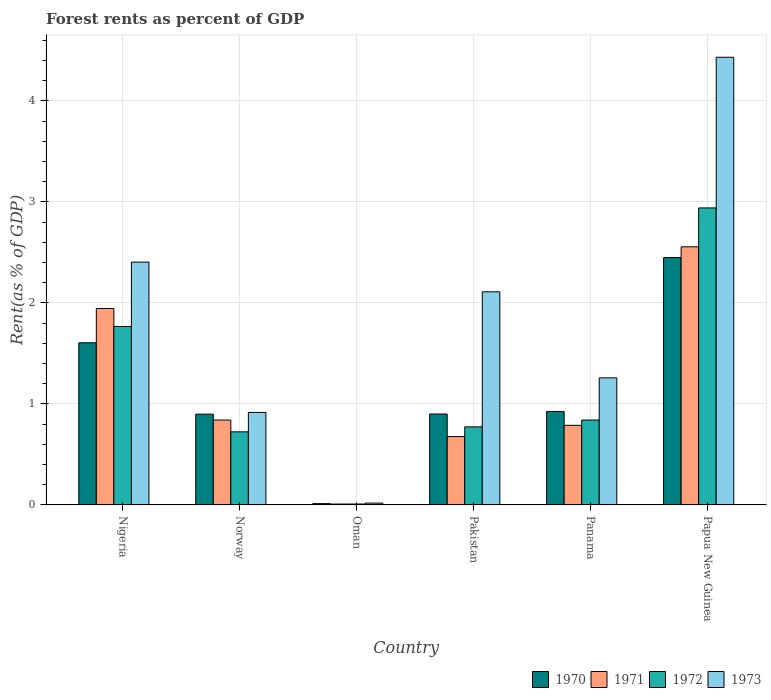How many different coloured bars are there?
Offer a very short reply. 4. How many groups of bars are there?
Your answer should be very brief. 6. How many bars are there on the 1st tick from the right?
Offer a very short reply. 4. What is the label of the 5th group of bars from the left?
Offer a terse response. Panama. In how many cases, is the number of bars for a given country not equal to the number of legend labels?
Offer a very short reply. 0. What is the forest rent in 1972 in Papua New Guinea?
Keep it short and to the point. 2.94. Across all countries, what is the maximum forest rent in 1973?
Provide a short and direct response. 4.43. Across all countries, what is the minimum forest rent in 1972?
Ensure brevity in your answer.  0.01. In which country was the forest rent in 1973 maximum?
Your answer should be very brief. Papua New Guinea. In which country was the forest rent in 1970 minimum?
Offer a very short reply. Oman. What is the total forest rent in 1970 in the graph?
Make the answer very short. 6.79. What is the difference between the forest rent in 1973 in Norway and that in Panama?
Keep it short and to the point. -0.34. What is the difference between the forest rent in 1973 in Pakistan and the forest rent in 1971 in Papua New Guinea?
Your answer should be very brief. -0.45. What is the average forest rent in 1973 per country?
Your answer should be very brief. 1.86. What is the difference between the forest rent of/in 1972 and forest rent of/in 1973 in Pakistan?
Ensure brevity in your answer.  -1.34. In how many countries, is the forest rent in 1972 greater than 4.2 %?
Keep it short and to the point. 0. What is the ratio of the forest rent in 1973 in Oman to that in Pakistan?
Your answer should be compact. 0.01. Is the difference between the forest rent in 1972 in Panama and Papua New Guinea greater than the difference between the forest rent in 1973 in Panama and Papua New Guinea?
Ensure brevity in your answer.  Yes. What is the difference between the highest and the second highest forest rent in 1970?
Give a very brief answer. -0.68. What is the difference between the highest and the lowest forest rent in 1970?
Give a very brief answer. 2.44. In how many countries, is the forest rent in 1973 greater than the average forest rent in 1973 taken over all countries?
Offer a very short reply. 3. Is the sum of the forest rent in 1973 in Oman and Papua New Guinea greater than the maximum forest rent in 1972 across all countries?
Provide a succinct answer. Yes. Is it the case that in every country, the sum of the forest rent in 1972 and forest rent in 1971 is greater than the sum of forest rent in 1970 and forest rent in 1973?
Your answer should be compact. No. What does the 3rd bar from the right in Oman represents?
Offer a very short reply. 1971. Is it the case that in every country, the sum of the forest rent in 1972 and forest rent in 1970 is greater than the forest rent in 1973?
Give a very brief answer. No. Are all the bars in the graph horizontal?
Make the answer very short. No. What is the difference between two consecutive major ticks on the Y-axis?
Your answer should be very brief. 1. Are the values on the major ticks of Y-axis written in scientific E-notation?
Your answer should be very brief. No. Where does the legend appear in the graph?
Your response must be concise. Bottom right. What is the title of the graph?
Your answer should be very brief. Forest rents as percent of GDP. What is the label or title of the Y-axis?
Give a very brief answer. Rent(as % of GDP). What is the Rent(as % of GDP) of 1970 in Nigeria?
Offer a terse response. 1.61. What is the Rent(as % of GDP) of 1971 in Nigeria?
Make the answer very short. 1.94. What is the Rent(as % of GDP) of 1972 in Nigeria?
Provide a succinct answer. 1.77. What is the Rent(as % of GDP) in 1973 in Nigeria?
Offer a very short reply. 2.4. What is the Rent(as % of GDP) in 1970 in Norway?
Your answer should be compact. 0.9. What is the Rent(as % of GDP) of 1971 in Norway?
Your answer should be compact. 0.84. What is the Rent(as % of GDP) of 1972 in Norway?
Ensure brevity in your answer.  0.72. What is the Rent(as % of GDP) of 1973 in Norway?
Give a very brief answer. 0.92. What is the Rent(as % of GDP) in 1970 in Oman?
Offer a terse response. 0.01. What is the Rent(as % of GDP) in 1971 in Oman?
Provide a short and direct response. 0.01. What is the Rent(as % of GDP) of 1972 in Oman?
Keep it short and to the point. 0.01. What is the Rent(as % of GDP) in 1973 in Oman?
Your response must be concise. 0.02. What is the Rent(as % of GDP) in 1970 in Pakistan?
Offer a terse response. 0.9. What is the Rent(as % of GDP) of 1971 in Pakistan?
Provide a succinct answer. 0.68. What is the Rent(as % of GDP) in 1972 in Pakistan?
Make the answer very short. 0.77. What is the Rent(as % of GDP) of 1973 in Pakistan?
Offer a terse response. 2.11. What is the Rent(as % of GDP) of 1970 in Panama?
Offer a very short reply. 0.93. What is the Rent(as % of GDP) in 1971 in Panama?
Provide a succinct answer. 0.79. What is the Rent(as % of GDP) in 1972 in Panama?
Offer a terse response. 0.84. What is the Rent(as % of GDP) of 1973 in Panama?
Provide a succinct answer. 1.26. What is the Rent(as % of GDP) of 1970 in Papua New Guinea?
Provide a succinct answer. 2.45. What is the Rent(as % of GDP) of 1971 in Papua New Guinea?
Your response must be concise. 2.56. What is the Rent(as % of GDP) in 1972 in Papua New Guinea?
Your answer should be compact. 2.94. What is the Rent(as % of GDP) of 1973 in Papua New Guinea?
Provide a short and direct response. 4.43. Across all countries, what is the maximum Rent(as % of GDP) in 1970?
Your answer should be compact. 2.45. Across all countries, what is the maximum Rent(as % of GDP) of 1971?
Offer a terse response. 2.56. Across all countries, what is the maximum Rent(as % of GDP) of 1972?
Give a very brief answer. 2.94. Across all countries, what is the maximum Rent(as % of GDP) of 1973?
Make the answer very short. 4.43. Across all countries, what is the minimum Rent(as % of GDP) of 1970?
Make the answer very short. 0.01. Across all countries, what is the minimum Rent(as % of GDP) of 1971?
Your answer should be compact. 0.01. Across all countries, what is the minimum Rent(as % of GDP) of 1972?
Your response must be concise. 0.01. Across all countries, what is the minimum Rent(as % of GDP) of 1973?
Your response must be concise. 0.02. What is the total Rent(as % of GDP) of 1970 in the graph?
Offer a very short reply. 6.79. What is the total Rent(as % of GDP) in 1971 in the graph?
Provide a succinct answer. 6.81. What is the total Rent(as % of GDP) in 1972 in the graph?
Your response must be concise. 7.05. What is the total Rent(as % of GDP) in 1973 in the graph?
Your answer should be compact. 11.14. What is the difference between the Rent(as % of GDP) of 1970 in Nigeria and that in Norway?
Ensure brevity in your answer.  0.71. What is the difference between the Rent(as % of GDP) in 1971 in Nigeria and that in Norway?
Make the answer very short. 1.1. What is the difference between the Rent(as % of GDP) of 1972 in Nigeria and that in Norway?
Ensure brevity in your answer.  1.04. What is the difference between the Rent(as % of GDP) in 1973 in Nigeria and that in Norway?
Your answer should be compact. 1.49. What is the difference between the Rent(as % of GDP) of 1970 in Nigeria and that in Oman?
Give a very brief answer. 1.59. What is the difference between the Rent(as % of GDP) of 1971 in Nigeria and that in Oman?
Provide a short and direct response. 1.94. What is the difference between the Rent(as % of GDP) in 1972 in Nigeria and that in Oman?
Offer a very short reply. 1.76. What is the difference between the Rent(as % of GDP) in 1973 in Nigeria and that in Oman?
Keep it short and to the point. 2.39. What is the difference between the Rent(as % of GDP) in 1970 in Nigeria and that in Pakistan?
Offer a terse response. 0.7. What is the difference between the Rent(as % of GDP) of 1971 in Nigeria and that in Pakistan?
Provide a short and direct response. 1.27. What is the difference between the Rent(as % of GDP) in 1973 in Nigeria and that in Pakistan?
Provide a short and direct response. 0.29. What is the difference between the Rent(as % of GDP) in 1970 in Nigeria and that in Panama?
Your answer should be very brief. 0.68. What is the difference between the Rent(as % of GDP) of 1971 in Nigeria and that in Panama?
Keep it short and to the point. 1.16. What is the difference between the Rent(as % of GDP) of 1972 in Nigeria and that in Panama?
Your response must be concise. 0.93. What is the difference between the Rent(as % of GDP) of 1973 in Nigeria and that in Panama?
Your answer should be very brief. 1.15. What is the difference between the Rent(as % of GDP) in 1970 in Nigeria and that in Papua New Guinea?
Offer a terse response. -0.84. What is the difference between the Rent(as % of GDP) of 1971 in Nigeria and that in Papua New Guinea?
Offer a terse response. -0.61. What is the difference between the Rent(as % of GDP) of 1972 in Nigeria and that in Papua New Guinea?
Offer a very short reply. -1.17. What is the difference between the Rent(as % of GDP) in 1973 in Nigeria and that in Papua New Guinea?
Ensure brevity in your answer.  -2.03. What is the difference between the Rent(as % of GDP) of 1970 in Norway and that in Oman?
Your answer should be compact. 0.89. What is the difference between the Rent(as % of GDP) in 1971 in Norway and that in Oman?
Your answer should be compact. 0.83. What is the difference between the Rent(as % of GDP) in 1972 in Norway and that in Oman?
Your answer should be compact. 0.71. What is the difference between the Rent(as % of GDP) of 1973 in Norway and that in Oman?
Make the answer very short. 0.9. What is the difference between the Rent(as % of GDP) in 1970 in Norway and that in Pakistan?
Provide a short and direct response. -0. What is the difference between the Rent(as % of GDP) in 1971 in Norway and that in Pakistan?
Your response must be concise. 0.16. What is the difference between the Rent(as % of GDP) of 1972 in Norway and that in Pakistan?
Provide a succinct answer. -0.05. What is the difference between the Rent(as % of GDP) of 1973 in Norway and that in Pakistan?
Give a very brief answer. -1.19. What is the difference between the Rent(as % of GDP) of 1970 in Norway and that in Panama?
Provide a succinct answer. -0.03. What is the difference between the Rent(as % of GDP) in 1971 in Norway and that in Panama?
Your answer should be compact. 0.05. What is the difference between the Rent(as % of GDP) of 1972 in Norway and that in Panama?
Offer a terse response. -0.12. What is the difference between the Rent(as % of GDP) of 1973 in Norway and that in Panama?
Give a very brief answer. -0.34. What is the difference between the Rent(as % of GDP) of 1970 in Norway and that in Papua New Guinea?
Your answer should be very brief. -1.55. What is the difference between the Rent(as % of GDP) of 1971 in Norway and that in Papua New Guinea?
Your answer should be compact. -1.72. What is the difference between the Rent(as % of GDP) in 1972 in Norway and that in Papua New Guinea?
Offer a terse response. -2.22. What is the difference between the Rent(as % of GDP) in 1973 in Norway and that in Papua New Guinea?
Your answer should be compact. -3.52. What is the difference between the Rent(as % of GDP) of 1970 in Oman and that in Pakistan?
Your answer should be compact. -0.89. What is the difference between the Rent(as % of GDP) of 1971 in Oman and that in Pakistan?
Keep it short and to the point. -0.67. What is the difference between the Rent(as % of GDP) of 1972 in Oman and that in Pakistan?
Offer a very short reply. -0.76. What is the difference between the Rent(as % of GDP) of 1973 in Oman and that in Pakistan?
Your response must be concise. -2.09. What is the difference between the Rent(as % of GDP) of 1970 in Oman and that in Panama?
Provide a succinct answer. -0.91. What is the difference between the Rent(as % of GDP) in 1971 in Oman and that in Panama?
Provide a succinct answer. -0.78. What is the difference between the Rent(as % of GDP) of 1972 in Oman and that in Panama?
Your response must be concise. -0.83. What is the difference between the Rent(as % of GDP) of 1973 in Oman and that in Panama?
Keep it short and to the point. -1.24. What is the difference between the Rent(as % of GDP) in 1970 in Oman and that in Papua New Guinea?
Ensure brevity in your answer.  -2.44. What is the difference between the Rent(as % of GDP) in 1971 in Oman and that in Papua New Guinea?
Provide a short and direct response. -2.55. What is the difference between the Rent(as % of GDP) of 1972 in Oman and that in Papua New Guinea?
Offer a terse response. -2.93. What is the difference between the Rent(as % of GDP) of 1973 in Oman and that in Papua New Guinea?
Give a very brief answer. -4.41. What is the difference between the Rent(as % of GDP) of 1970 in Pakistan and that in Panama?
Your response must be concise. -0.03. What is the difference between the Rent(as % of GDP) of 1971 in Pakistan and that in Panama?
Offer a terse response. -0.11. What is the difference between the Rent(as % of GDP) of 1972 in Pakistan and that in Panama?
Keep it short and to the point. -0.07. What is the difference between the Rent(as % of GDP) of 1973 in Pakistan and that in Panama?
Give a very brief answer. 0.85. What is the difference between the Rent(as % of GDP) of 1970 in Pakistan and that in Papua New Guinea?
Your response must be concise. -1.55. What is the difference between the Rent(as % of GDP) in 1971 in Pakistan and that in Papua New Guinea?
Offer a terse response. -1.88. What is the difference between the Rent(as % of GDP) in 1972 in Pakistan and that in Papua New Guinea?
Give a very brief answer. -2.17. What is the difference between the Rent(as % of GDP) in 1973 in Pakistan and that in Papua New Guinea?
Give a very brief answer. -2.32. What is the difference between the Rent(as % of GDP) of 1970 in Panama and that in Papua New Guinea?
Provide a succinct answer. -1.52. What is the difference between the Rent(as % of GDP) in 1971 in Panama and that in Papua New Guinea?
Your answer should be very brief. -1.77. What is the difference between the Rent(as % of GDP) of 1973 in Panama and that in Papua New Guinea?
Offer a terse response. -3.17. What is the difference between the Rent(as % of GDP) of 1970 in Nigeria and the Rent(as % of GDP) of 1971 in Norway?
Provide a succinct answer. 0.76. What is the difference between the Rent(as % of GDP) in 1970 in Nigeria and the Rent(as % of GDP) in 1972 in Norway?
Offer a terse response. 0.88. What is the difference between the Rent(as % of GDP) in 1970 in Nigeria and the Rent(as % of GDP) in 1973 in Norway?
Your answer should be very brief. 0.69. What is the difference between the Rent(as % of GDP) of 1971 in Nigeria and the Rent(as % of GDP) of 1972 in Norway?
Provide a succinct answer. 1.22. What is the difference between the Rent(as % of GDP) of 1972 in Nigeria and the Rent(as % of GDP) of 1973 in Norway?
Your answer should be compact. 0.85. What is the difference between the Rent(as % of GDP) of 1970 in Nigeria and the Rent(as % of GDP) of 1971 in Oman?
Ensure brevity in your answer.  1.6. What is the difference between the Rent(as % of GDP) of 1970 in Nigeria and the Rent(as % of GDP) of 1972 in Oman?
Your response must be concise. 1.6. What is the difference between the Rent(as % of GDP) of 1970 in Nigeria and the Rent(as % of GDP) of 1973 in Oman?
Offer a terse response. 1.59. What is the difference between the Rent(as % of GDP) in 1971 in Nigeria and the Rent(as % of GDP) in 1972 in Oman?
Offer a very short reply. 1.94. What is the difference between the Rent(as % of GDP) of 1971 in Nigeria and the Rent(as % of GDP) of 1973 in Oman?
Your answer should be compact. 1.93. What is the difference between the Rent(as % of GDP) in 1972 in Nigeria and the Rent(as % of GDP) in 1973 in Oman?
Provide a succinct answer. 1.75. What is the difference between the Rent(as % of GDP) of 1970 in Nigeria and the Rent(as % of GDP) of 1971 in Pakistan?
Provide a short and direct response. 0.93. What is the difference between the Rent(as % of GDP) of 1970 in Nigeria and the Rent(as % of GDP) of 1972 in Pakistan?
Offer a terse response. 0.83. What is the difference between the Rent(as % of GDP) of 1970 in Nigeria and the Rent(as % of GDP) of 1973 in Pakistan?
Provide a succinct answer. -0.5. What is the difference between the Rent(as % of GDP) in 1971 in Nigeria and the Rent(as % of GDP) in 1972 in Pakistan?
Provide a succinct answer. 1.17. What is the difference between the Rent(as % of GDP) of 1971 in Nigeria and the Rent(as % of GDP) of 1973 in Pakistan?
Provide a succinct answer. -0.17. What is the difference between the Rent(as % of GDP) of 1972 in Nigeria and the Rent(as % of GDP) of 1973 in Pakistan?
Provide a short and direct response. -0.34. What is the difference between the Rent(as % of GDP) of 1970 in Nigeria and the Rent(as % of GDP) of 1971 in Panama?
Offer a very short reply. 0.82. What is the difference between the Rent(as % of GDP) in 1970 in Nigeria and the Rent(as % of GDP) in 1972 in Panama?
Provide a succinct answer. 0.76. What is the difference between the Rent(as % of GDP) in 1970 in Nigeria and the Rent(as % of GDP) in 1973 in Panama?
Offer a very short reply. 0.35. What is the difference between the Rent(as % of GDP) of 1971 in Nigeria and the Rent(as % of GDP) of 1972 in Panama?
Your answer should be compact. 1.1. What is the difference between the Rent(as % of GDP) in 1971 in Nigeria and the Rent(as % of GDP) in 1973 in Panama?
Give a very brief answer. 0.69. What is the difference between the Rent(as % of GDP) of 1972 in Nigeria and the Rent(as % of GDP) of 1973 in Panama?
Your answer should be compact. 0.51. What is the difference between the Rent(as % of GDP) in 1970 in Nigeria and the Rent(as % of GDP) in 1971 in Papua New Guinea?
Keep it short and to the point. -0.95. What is the difference between the Rent(as % of GDP) of 1970 in Nigeria and the Rent(as % of GDP) of 1972 in Papua New Guinea?
Your response must be concise. -1.34. What is the difference between the Rent(as % of GDP) of 1970 in Nigeria and the Rent(as % of GDP) of 1973 in Papua New Guinea?
Keep it short and to the point. -2.83. What is the difference between the Rent(as % of GDP) in 1971 in Nigeria and the Rent(as % of GDP) in 1972 in Papua New Guinea?
Your response must be concise. -1. What is the difference between the Rent(as % of GDP) in 1971 in Nigeria and the Rent(as % of GDP) in 1973 in Papua New Guinea?
Your answer should be compact. -2.49. What is the difference between the Rent(as % of GDP) of 1972 in Nigeria and the Rent(as % of GDP) of 1973 in Papua New Guinea?
Make the answer very short. -2.66. What is the difference between the Rent(as % of GDP) of 1970 in Norway and the Rent(as % of GDP) of 1971 in Oman?
Your answer should be very brief. 0.89. What is the difference between the Rent(as % of GDP) in 1970 in Norway and the Rent(as % of GDP) in 1972 in Oman?
Your answer should be compact. 0.89. What is the difference between the Rent(as % of GDP) of 1970 in Norway and the Rent(as % of GDP) of 1973 in Oman?
Offer a very short reply. 0.88. What is the difference between the Rent(as % of GDP) of 1971 in Norway and the Rent(as % of GDP) of 1972 in Oman?
Offer a terse response. 0.83. What is the difference between the Rent(as % of GDP) of 1971 in Norway and the Rent(as % of GDP) of 1973 in Oman?
Your response must be concise. 0.82. What is the difference between the Rent(as % of GDP) in 1972 in Norway and the Rent(as % of GDP) in 1973 in Oman?
Your response must be concise. 0.71. What is the difference between the Rent(as % of GDP) in 1970 in Norway and the Rent(as % of GDP) in 1971 in Pakistan?
Your answer should be very brief. 0.22. What is the difference between the Rent(as % of GDP) in 1970 in Norway and the Rent(as % of GDP) in 1972 in Pakistan?
Make the answer very short. 0.13. What is the difference between the Rent(as % of GDP) in 1970 in Norway and the Rent(as % of GDP) in 1973 in Pakistan?
Provide a short and direct response. -1.21. What is the difference between the Rent(as % of GDP) of 1971 in Norway and the Rent(as % of GDP) of 1972 in Pakistan?
Offer a very short reply. 0.07. What is the difference between the Rent(as % of GDP) in 1971 in Norway and the Rent(as % of GDP) in 1973 in Pakistan?
Offer a very short reply. -1.27. What is the difference between the Rent(as % of GDP) of 1972 in Norway and the Rent(as % of GDP) of 1973 in Pakistan?
Your response must be concise. -1.39. What is the difference between the Rent(as % of GDP) in 1970 in Norway and the Rent(as % of GDP) in 1971 in Panama?
Offer a terse response. 0.11. What is the difference between the Rent(as % of GDP) in 1970 in Norway and the Rent(as % of GDP) in 1972 in Panama?
Your answer should be compact. 0.06. What is the difference between the Rent(as % of GDP) of 1970 in Norway and the Rent(as % of GDP) of 1973 in Panama?
Your response must be concise. -0.36. What is the difference between the Rent(as % of GDP) of 1971 in Norway and the Rent(as % of GDP) of 1973 in Panama?
Provide a succinct answer. -0.42. What is the difference between the Rent(as % of GDP) of 1972 in Norway and the Rent(as % of GDP) of 1973 in Panama?
Give a very brief answer. -0.53. What is the difference between the Rent(as % of GDP) in 1970 in Norway and the Rent(as % of GDP) in 1971 in Papua New Guinea?
Provide a short and direct response. -1.66. What is the difference between the Rent(as % of GDP) of 1970 in Norway and the Rent(as % of GDP) of 1972 in Papua New Guinea?
Give a very brief answer. -2.04. What is the difference between the Rent(as % of GDP) in 1970 in Norway and the Rent(as % of GDP) in 1973 in Papua New Guinea?
Your answer should be very brief. -3.53. What is the difference between the Rent(as % of GDP) of 1971 in Norway and the Rent(as % of GDP) of 1972 in Papua New Guinea?
Keep it short and to the point. -2.1. What is the difference between the Rent(as % of GDP) of 1971 in Norway and the Rent(as % of GDP) of 1973 in Papua New Guinea?
Your answer should be compact. -3.59. What is the difference between the Rent(as % of GDP) in 1972 in Norway and the Rent(as % of GDP) in 1973 in Papua New Guinea?
Provide a succinct answer. -3.71. What is the difference between the Rent(as % of GDP) of 1970 in Oman and the Rent(as % of GDP) of 1971 in Pakistan?
Offer a terse response. -0.66. What is the difference between the Rent(as % of GDP) of 1970 in Oman and the Rent(as % of GDP) of 1972 in Pakistan?
Offer a terse response. -0.76. What is the difference between the Rent(as % of GDP) of 1970 in Oman and the Rent(as % of GDP) of 1973 in Pakistan?
Keep it short and to the point. -2.1. What is the difference between the Rent(as % of GDP) in 1971 in Oman and the Rent(as % of GDP) in 1972 in Pakistan?
Offer a terse response. -0.76. What is the difference between the Rent(as % of GDP) of 1971 in Oman and the Rent(as % of GDP) of 1973 in Pakistan?
Your answer should be very brief. -2.1. What is the difference between the Rent(as % of GDP) of 1972 in Oman and the Rent(as % of GDP) of 1973 in Pakistan?
Offer a terse response. -2.1. What is the difference between the Rent(as % of GDP) in 1970 in Oman and the Rent(as % of GDP) in 1971 in Panama?
Keep it short and to the point. -0.78. What is the difference between the Rent(as % of GDP) in 1970 in Oman and the Rent(as % of GDP) in 1972 in Panama?
Your answer should be very brief. -0.83. What is the difference between the Rent(as % of GDP) in 1970 in Oman and the Rent(as % of GDP) in 1973 in Panama?
Your response must be concise. -1.25. What is the difference between the Rent(as % of GDP) of 1971 in Oman and the Rent(as % of GDP) of 1972 in Panama?
Provide a short and direct response. -0.83. What is the difference between the Rent(as % of GDP) of 1971 in Oman and the Rent(as % of GDP) of 1973 in Panama?
Provide a succinct answer. -1.25. What is the difference between the Rent(as % of GDP) in 1972 in Oman and the Rent(as % of GDP) in 1973 in Panama?
Offer a terse response. -1.25. What is the difference between the Rent(as % of GDP) in 1970 in Oman and the Rent(as % of GDP) in 1971 in Papua New Guinea?
Keep it short and to the point. -2.54. What is the difference between the Rent(as % of GDP) of 1970 in Oman and the Rent(as % of GDP) of 1972 in Papua New Guinea?
Offer a very short reply. -2.93. What is the difference between the Rent(as % of GDP) in 1970 in Oman and the Rent(as % of GDP) in 1973 in Papua New Guinea?
Your answer should be very brief. -4.42. What is the difference between the Rent(as % of GDP) in 1971 in Oman and the Rent(as % of GDP) in 1972 in Papua New Guinea?
Offer a terse response. -2.93. What is the difference between the Rent(as % of GDP) of 1971 in Oman and the Rent(as % of GDP) of 1973 in Papua New Guinea?
Keep it short and to the point. -4.42. What is the difference between the Rent(as % of GDP) of 1972 in Oman and the Rent(as % of GDP) of 1973 in Papua New Guinea?
Make the answer very short. -4.42. What is the difference between the Rent(as % of GDP) in 1970 in Pakistan and the Rent(as % of GDP) in 1971 in Panama?
Ensure brevity in your answer.  0.11. What is the difference between the Rent(as % of GDP) of 1970 in Pakistan and the Rent(as % of GDP) of 1972 in Panama?
Offer a very short reply. 0.06. What is the difference between the Rent(as % of GDP) in 1970 in Pakistan and the Rent(as % of GDP) in 1973 in Panama?
Your answer should be compact. -0.36. What is the difference between the Rent(as % of GDP) in 1971 in Pakistan and the Rent(as % of GDP) in 1972 in Panama?
Ensure brevity in your answer.  -0.16. What is the difference between the Rent(as % of GDP) in 1971 in Pakistan and the Rent(as % of GDP) in 1973 in Panama?
Ensure brevity in your answer.  -0.58. What is the difference between the Rent(as % of GDP) of 1972 in Pakistan and the Rent(as % of GDP) of 1973 in Panama?
Your response must be concise. -0.49. What is the difference between the Rent(as % of GDP) of 1970 in Pakistan and the Rent(as % of GDP) of 1971 in Papua New Guinea?
Your response must be concise. -1.66. What is the difference between the Rent(as % of GDP) in 1970 in Pakistan and the Rent(as % of GDP) in 1972 in Papua New Guinea?
Make the answer very short. -2.04. What is the difference between the Rent(as % of GDP) in 1970 in Pakistan and the Rent(as % of GDP) in 1973 in Papua New Guinea?
Your response must be concise. -3.53. What is the difference between the Rent(as % of GDP) of 1971 in Pakistan and the Rent(as % of GDP) of 1972 in Papua New Guinea?
Keep it short and to the point. -2.26. What is the difference between the Rent(as % of GDP) of 1971 in Pakistan and the Rent(as % of GDP) of 1973 in Papua New Guinea?
Keep it short and to the point. -3.76. What is the difference between the Rent(as % of GDP) of 1972 in Pakistan and the Rent(as % of GDP) of 1973 in Papua New Guinea?
Your answer should be very brief. -3.66. What is the difference between the Rent(as % of GDP) of 1970 in Panama and the Rent(as % of GDP) of 1971 in Papua New Guinea?
Offer a terse response. -1.63. What is the difference between the Rent(as % of GDP) of 1970 in Panama and the Rent(as % of GDP) of 1972 in Papua New Guinea?
Offer a very short reply. -2.01. What is the difference between the Rent(as % of GDP) in 1970 in Panama and the Rent(as % of GDP) in 1973 in Papua New Guinea?
Your answer should be compact. -3.51. What is the difference between the Rent(as % of GDP) of 1971 in Panama and the Rent(as % of GDP) of 1972 in Papua New Guinea?
Offer a very short reply. -2.15. What is the difference between the Rent(as % of GDP) in 1971 in Panama and the Rent(as % of GDP) in 1973 in Papua New Guinea?
Your answer should be compact. -3.64. What is the difference between the Rent(as % of GDP) of 1972 in Panama and the Rent(as % of GDP) of 1973 in Papua New Guinea?
Offer a very short reply. -3.59. What is the average Rent(as % of GDP) in 1970 per country?
Make the answer very short. 1.13. What is the average Rent(as % of GDP) of 1971 per country?
Provide a succinct answer. 1.14. What is the average Rent(as % of GDP) in 1972 per country?
Your response must be concise. 1.18. What is the average Rent(as % of GDP) in 1973 per country?
Offer a very short reply. 1.86. What is the difference between the Rent(as % of GDP) of 1970 and Rent(as % of GDP) of 1971 in Nigeria?
Offer a terse response. -0.34. What is the difference between the Rent(as % of GDP) of 1970 and Rent(as % of GDP) of 1972 in Nigeria?
Offer a terse response. -0.16. What is the difference between the Rent(as % of GDP) in 1970 and Rent(as % of GDP) in 1973 in Nigeria?
Offer a terse response. -0.8. What is the difference between the Rent(as % of GDP) of 1971 and Rent(as % of GDP) of 1972 in Nigeria?
Offer a very short reply. 0.18. What is the difference between the Rent(as % of GDP) in 1971 and Rent(as % of GDP) in 1973 in Nigeria?
Provide a short and direct response. -0.46. What is the difference between the Rent(as % of GDP) in 1972 and Rent(as % of GDP) in 1973 in Nigeria?
Make the answer very short. -0.64. What is the difference between the Rent(as % of GDP) of 1970 and Rent(as % of GDP) of 1971 in Norway?
Provide a short and direct response. 0.06. What is the difference between the Rent(as % of GDP) in 1970 and Rent(as % of GDP) in 1972 in Norway?
Your answer should be compact. 0.17. What is the difference between the Rent(as % of GDP) of 1970 and Rent(as % of GDP) of 1973 in Norway?
Your response must be concise. -0.02. What is the difference between the Rent(as % of GDP) in 1971 and Rent(as % of GDP) in 1972 in Norway?
Provide a short and direct response. 0.12. What is the difference between the Rent(as % of GDP) in 1971 and Rent(as % of GDP) in 1973 in Norway?
Your response must be concise. -0.08. What is the difference between the Rent(as % of GDP) of 1972 and Rent(as % of GDP) of 1973 in Norway?
Provide a short and direct response. -0.19. What is the difference between the Rent(as % of GDP) in 1970 and Rent(as % of GDP) in 1971 in Oman?
Your answer should be compact. 0. What is the difference between the Rent(as % of GDP) of 1970 and Rent(as % of GDP) of 1972 in Oman?
Give a very brief answer. 0. What is the difference between the Rent(as % of GDP) in 1970 and Rent(as % of GDP) in 1973 in Oman?
Ensure brevity in your answer.  -0.01. What is the difference between the Rent(as % of GDP) of 1971 and Rent(as % of GDP) of 1972 in Oman?
Ensure brevity in your answer.  -0. What is the difference between the Rent(as % of GDP) in 1971 and Rent(as % of GDP) in 1973 in Oman?
Offer a terse response. -0.01. What is the difference between the Rent(as % of GDP) in 1972 and Rent(as % of GDP) in 1973 in Oman?
Give a very brief answer. -0.01. What is the difference between the Rent(as % of GDP) of 1970 and Rent(as % of GDP) of 1971 in Pakistan?
Ensure brevity in your answer.  0.22. What is the difference between the Rent(as % of GDP) of 1970 and Rent(as % of GDP) of 1972 in Pakistan?
Ensure brevity in your answer.  0.13. What is the difference between the Rent(as % of GDP) in 1970 and Rent(as % of GDP) in 1973 in Pakistan?
Give a very brief answer. -1.21. What is the difference between the Rent(as % of GDP) of 1971 and Rent(as % of GDP) of 1972 in Pakistan?
Your answer should be very brief. -0.1. What is the difference between the Rent(as % of GDP) in 1971 and Rent(as % of GDP) in 1973 in Pakistan?
Offer a very short reply. -1.43. What is the difference between the Rent(as % of GDP) of 1972 and Rent(as % of GDP) of 1973 in Pakistan?
Offer a very short reply. -1.34. What is the difference between the Rent(as % of GDP) in 1970 and Rent(as % of GDP) in 1971 in Panama?
Your response must be concise. 0.14. What is the difference between the Rent(as % of GDP) in 1970 and Rent(as % of GDP) in 1972 in Panama?
Offer a very short reply. 0.09. What is the difference between the Rent(as % of GDP) of 1970 and Rent(as % of GDP) of 1973 in Panama?
Ensure brevity in your answer.  -0.33. What is the difference between the Rent(as % of GDP) of 1971 and Rent(as % of GDP) of 1972 in Panama?
Ensure brevity in your answer.  -0.05. What is the difference between the Rent(as % of GDP) of 1971 and Rent(as % of GDP) of 1973 in Panama?
Your response must be concise. -0.47. What is the difference between the Rent(as % of GDP) in 1972 and Rent(as % of GDP) in 1973 in Panama?
Provide a succinct answer. -0.42. What is the difference between the Rent(as % of GDP) in 1970 and Rent(as % of GDP) in 1971 in Papua New Guinea?
Keep it short and to the point. -0.11. What is the difference between the Rent(as % of GDP) in 1970 and Rent(as % of GDP) in 1972 in Papua New Guinea?
Provide a succinct answer. -0.49. What is the difference between the Rent(as % of GDP) of 1970 and Rent(as % of GDP) of 1973 in Papua New Guinea?
Provide a short and direct response. -1.98. What is the difference between the Rent(as % of GDP) in 1971 and Rent(as % of GDP) in 1972 in Papua New Guinea?
Offer a very short reply. -0.38. What is the difference between the Rent(as % of GDP) of 1971 and Rent(as % of GDP) of 1973 in Papua New Guinea?
Give a very brief answer. -1.88. What is the difference between the Rent(as % of GDP) in 1972 and Rent(as % of GDP) in 1973 in Papua New Guinea?
Offer a very short reply. -1.49. What is the ratio of the Rent(as % of GDP) in 1970 in Nigeria to that in Norway?
Keep it short and to the point. 1.79. What is the ratio of the Rent(as % of GDP) in 1971 in Nigeria to that in Norway?
Provide a short and direct response. 2.31. What is the ratio of the Rent(as % of GDP) of 1972 in Nigeria to that in Norway?
Provide a short and direct response. 2.44. What is the ratio of the Rent(as % of GDP) of 1973 in Nigeria to that in Norway?
Provide a short and direct response. 2.63. What is the ratio of the Rent(as % of GDP) in 1970 in Nigeria to that in Oman?
Provide a succinct answer. 123.51. What is the ratio of the Rent(as % of GDP) in 1971 in Nigeria to that in Oman?
Make the answer very short. 220.65. What is the ratio of the Rent(as % of GDP) in 1972 in Nigeria to that in Oman?
Your response must be concise. 191.74. What is the ratio of the Rent(as % of GDP) in 1973 in Nigeria to that in Oman?
Offer a terse response. 131.53. What is the ratio of the Rent(as % of GDP) in 1970 in Nigeria to that in Pakistan?
Make the answer very short. 1.78. What is the ratio of the Rent(as % of GDP) of 1971 in Nigeria to that in Pakistan?
Make the answer very short. 2.87. What is the ratio of the Rent(as % of GDP) in 1972 in Nigeria to that in Pakistan?
Offer a terse response. 2.29. What is the ratio of the Rent(as % of GDP) of 1973 in Nigeria to that in Pakistan?
Your response must be concise. 1.14. What is the ratio of the Rent(as % of GDP) in 1970 in Nigeria to that in Panama?
Your answer should be very brief. 1.73. What is the ratio of the Rent(as % of GDP) in 1971 in Nigeria to that in Panama?
Provide a succinct answer. 2.47. What is the ratio of the Rent(as % of GDP) of 1972 in Nigeria to that in Panama?
Ensure brevity in your answer.  2.1. What is the ratio of the Rent(as % of GDP) of 1973 in Nigeria to that in Panama?
Your answer should be very brief. 1.91. What is the ratio of the Rent(as % of GDP) in 1970 in Nigeria to that in Papua New Guinea?
Your response must be concise. 0.66. What is the ratio of the Rent(as % of GDP) of 1971 in Nigeria to that in Papua New Guinea?
Give a very brief answer. 0.76. What is the ratio of the Rent(as % of GDP) in 1972 in Nigeria to that in Papua New Guinea?
Keep it short and to the point. 0.6. What is the ratio of the Rent(as % of GDP) of 1973 in Nigeria to that in Papua New Guinea?
Make the answer very short. 0.54. What is the ratio of the Rent(as % of GDP) of 1970 in Norway to that in Oman?
Your response must be concise. 69.14. What is the ratio of the Rent(as % of GDP) in 1971 in Norway to that in Oman?
Give a very brief answer. 95.36. What is the ratio of the Rent(as % of GDP) in 1972 in Norway to that in Oman?
Your answer should be very brief. 78.53. What is the ratio of the Rent(as % of GDP) of 1973 in Norway to that in Oman?
Provide a succinct answer. 50.09. What is the ratio of the Rent(as % of GDP) of 1971 in Norway to that in Pakistan?
Ensure brevity in your answer.  1.24. What is the ratio of the Rent(as % of GDP) in 1972 in Norway to that in Pakistan?
Provide a succinct answer. 0.94. What is the ratio of the Rent(as % of GDP) in 1973 in Norway to that in Pakistan?
Your answer should be very brief. 0.43. What is the ratio of the Rent(as % of GDP) in 1970 in Norway to that in Panama?
Ensure brevity in your answer.  0.97. What is the ratio of the Rent(as % of GDP) of 1971 in Norway to that in Panama?
Offer a terse response. 1.07. What is the ratio of the Rent(as % of GDP) of 1972 in Norway to that in Panama?
Keep it short and to the point. 0.86. What is the ratio of the Rent(as % of GDP) in 1973 in Norway to that in Panama?
Keep it short and to the point. 0.73. What is the ratio of the Rent(as % of GDP) of 1970 in Norway to that in Papua New Guinea?
Provide a succinct answer. 0.37. What is the ratio of the Rent(as % of GDP) in 1971 in Norway to that in Papua New Guinea?
Provide a succinct answer. 0.33. What is the ratio of the Rent(as % of GDP) of 1972 in Norway to that in Papua New Guinea?
Your response must be concise. 0.25. What is the ratio of the Rent(as % of GDP) of 1973 in Norway to that in Papua New Guinea?
Make the answer very short. 0.21. What is the ratio of the Rent(as % of GDP) of 1970 in Oman to that in Pakistan?
Your response must be concise. 0.01. What is the ratio of the Rent(as % of GDP) in 1971 in Oman to that in Pakistan?
Give a very brief answer. 0.01. What is the ratio of the Rent(as % of GDP) of 1972 in Oman to that in Pakistan?
Keep it short and to the point. 0.01. What is the ratio of the Rent(as % of GDP) in 1973 in Oman to that in Pakistan?
Your response must be concise. 0.01. What is the ratio of the Rent(as % of GDP) of 1970 in Oman to that in Panama?
Keep it short and to the point. 0.01. What is the ratio of the Rent(as % of GDP) of 1971 in Oman to that in Panama?
Provide a short and direct response. 0.01. What is the ratio of the Rent(as % of GDP) of 1972 in Oman to that in Panama?
Offer a terse response. 0.01. What is the ratio of the Rent(as % of GDP) of 1973 in Oman to that in Panama?
Ensure brevity in your answer.  0.01. What is the ratio of the Rent(as % of GDP) in 1970 in Oman to that in Papua New Guinea?
Give a very brief answer. 0.01. What is the ratio of the Rent(as % of GDP) in 1971 in Oman to that in Papua New Guinea?
Ensure brevity in your answer.  0. What is the ratio of the Rent(as % of GDP) in 1972 in Oman to that in Papua New Guinea?
Ensure brevity in your answer.  0. What is the ratio of the Rent(as % of GDP) of 1973 in Oman to that in Papua New Guinea?
Your response must be concise. 0. What is the ratio of the Rent(as % of GDP) of 1970 in Pakistan to that in Panama?
Your response must be concise. 0.97. What is the ratio of the Rent(as % of GDP) of 1971 in Pakistan to that in Panama?
Give a very brief answer. 0.86. What is the ratio of the Rent(as % of GDP) of 1972 in Pakistan to that in Panama?
Provide a succinct answer. 0.92. What is the ratio of the Rent(as % of GDP) in 1973 in Pakistan to that in Panama?
Provide a succinct answer. 1.68. What is the ratio of the Rent(as % of GDP) in 1970 in Pakistan to that in Papua New Guinea?
Your response must be concise. 0.37. What is the ratio of the Rent(as % of GDP) in 1971 in Pakistan to that in Papua New Guinea?
Ensure brevity in your answer.  0.26. What is the ratio of the Rent(as % of GDP) in 1972 in Pakistan to that in Papua New Guinea?
Keep it short and to the point. 0.26. What is the ratio of the Rent(as % of GDP) in 1973 in Pakistan to that in Papua New Guinea?
Ensure brevity in your answer.  0.48. What is the ratio of the Rent(as % of GDP) of 1970 in Panama to that in Papua New Guinea?
Provide a short and direct response. 0.38. What is the ratio of the Rent(as % of GDP) in 1971 in Panama to that in Papua New Guinea?
Your answer should be very brief. 0.31. What is the ratio of the Rent(as % of GDP) in 1972 in Panama to that in Papua New Guinea?
Your answer should be very brief. 0.29. What is the ratio of the Rent(as % of GDP) of 1973 in Panama to that in Papua New Guinea?
Your answer should be very brief. 0.28. What is the difference between the highest and the second highest Rent(as % of GDP) of 1970?
Provide a short and direct response. 0.84. What is the difference between the highest and the second highest Rent(as % of GDP) of 1971?
Ensure brevity in your answer.  0.61. What is the difference between the highest and the second highest Rent(as % of GDP) in 1972?
Your answer should be compact. 1.17. What is the difference between the highest and the second highest Rent(as % of GDP) of 1973?
Provide a succinct answer. 2.03. What is the difference between the highest and the lowest Rent(as % of GDP) of 1970?
Give a very brief answer. 2.44. What is the difference between the highest and the lowest Rent(as % of GDP) in 1971?
Make the answer very short. 2.55. What is the difference between the highest and the lowest Rent(as % of GDP) of 1972?
Make the answer very short. 2.93. What is the difference between the highest and the lowest Rent(as % of GDP) in 1973?
Your response must be concise. 4.41. 